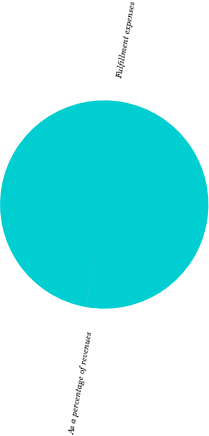Convert chart. <chart><loc_0><loc_0><loc_500><loc_500><pie_chart><fcel>Fulfillment expenses<fcel>As a percentage of revenues<nl><fcel>99.99%<fcel>0.01%<nl></chart> 